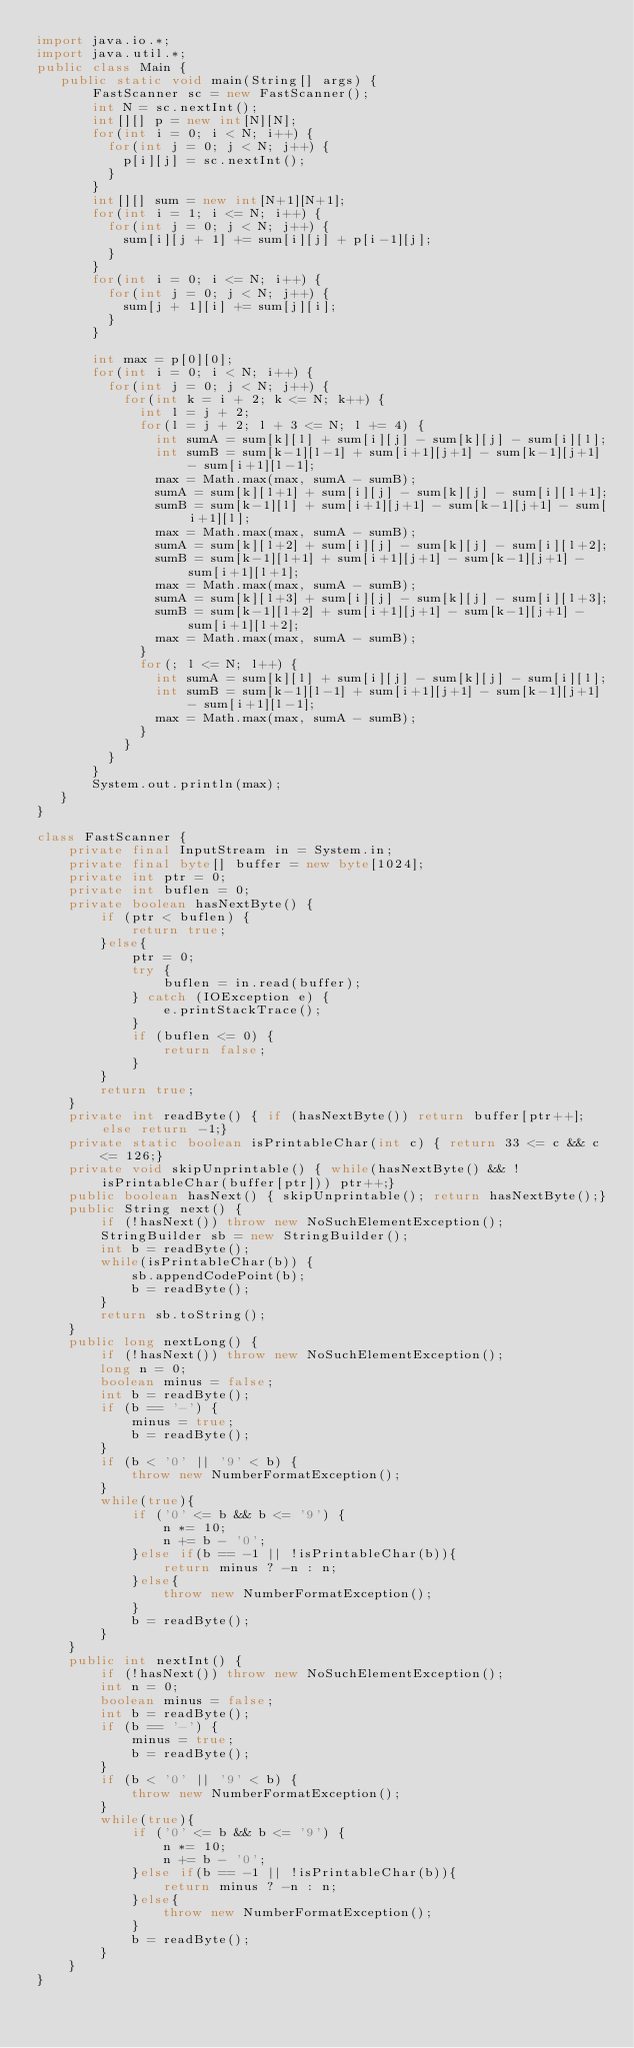<code> <loc_0><loc_0><loc_500><loc_500><_Java_>import java.io.*;
import java.util.*;
public class Main {
   public static void main(String[] args) {
       FastScanner sc = new FastScanner();
       int N = sc.nextInt();
       int[][] p = new int[N][N];
       for(int i = 0; i < N; i++) {
    	   for(int j = 0; j < N; j++) {
    		   p[i][j] = sc.nextInt();
    	   }
       }
       int[][] sum = new int[N+1][N+1];
       for(int i = 1; i <= N; i++) {
    	   for(int j = 0; j < N; j++) {
    		   sum[i][j + 1] += sum[i][j] + p[i-1][j];
    	   }
       }
       for(int i = 0; i <= N; i++) {
    	   for(int j = 0; j < N; j++) {
    		   sum[j + 1][i] += sum[j][i];
    	   }
       }
       
       int max = p[0][0];
       for(int i = 0; i < N; i++) {
    	   for(int j = 0; j < N; j++) {
    		   for(int k = i + 2; k <= N; k++) {
    			   int l = j + 2;
    			   for(l = j + 2; l + 3 <= N; l += 4) {
    				   int sumA = sum[k][l] + sum[i][j] - sum[k][j] - sum[i][l];
    				   int sumB = sum[k-1][l-1] + sum[i+1][j+1] - sum[k-1][j+1] - sum[i+1][l-1];
    				   max = Math.max(max, sumA - sumB);
    				   sumA = sum[k][l+1] + sum[i][j] - sum[k][j] - sum[i][l+1];
    				   sumB = sum[k-1][l] + sum[i+1][j+1] - sum[k-1][j+1] - sum[i+1][l];
    				   max = Math.max(max, sumA - sumB);
    				   sumA = sum[k][l+2] + sum[i][j] - sum[k][j] - sum[i][l+2];
    				   sumB = sum[k-1][l+1] + sum[i+1][j+1] - sum[k-1][j+1] - sum[i+1][l+1];
    				   max = Math.max(max, sumA - sumB);
    				   sumA = sum[k][l+3] + sum[i][j] - sum[k][j] - sum[i][l+3];
    				   sumB = sum[k-1][l+2] + sum[i+1][j+1] - sum[k-1][j+1] - sum[i+1][l+2];
    				   max = Math.max(max, sumA - sumB);
    			   }
    			   for(; l <= N; l++) {
    				   int sumA = sum[k][l] + sum[i][j] - sum[k][j] - sum[i][l];
    				   int sumB = sum[k-1][l-1] + sum[i+1][j+1] - sum[k-1][j+1] - sum[i+1][l-1];
    				   max = Math.max(max, sumA - sumB);
    			   }
    		   }
    	   }
       }
       System.out.println(max);
   }
}

class FastScanner {
    private final InputStream in = System.in;
    private final byte[] buffer = new byte[1024];
    private int ptr = 0;
    private int buflen = 0;
    private boolean hasNextByte() {
        if (ptr < buflen) {
            return true;
        }else{
            ptr = 0;
            try {
                buflen = in.read(buffer);
            } catch (IOException e) {
                e.printStackTrace();
            }
            if (buflen <= 0) {
                return false;
            }
        }
        return true;
    }
    private int readByte() { if (hasNextByte()) return buffer[ptr++]; else return -1;}
    private static boolean isPrintableChar(int c) { return 33 <= c && c <= 126;}
    private void skipUnprintable() { while(hasNextByte() && !isPrintableChar(buffer[ptr])) ptr++;}
    public boolean hasNext() { skipUnprintable(); return hasNextByte();}
    public String next() {
        if (!hasNext()) throw new NoSuchElementException();
        StringBuilder sb = new StringBuilder();
        int b = readByte();
        while(isPrintableChar(b)) {
            sb.appendCodePoint(b);
            b = readByte();
        }
        return sb.toString();
    }
    public long nextLong() {
        if (!hasNext()) throw new NoSuchElementException();
        long n = 0;
        boolean minus = false;
        int b = readByte();
        if (b == '-') {
            minus = true;
            b = readByte();
        }
        if (b < '0' || '9' < b) {
            throw new NumberFormatException();
        }
        while(true){
            if ('0' <= b && b <= '9') {
                n *= 10;
                n += b - '0';
            }else if(b == -1 || !isPrintableChar(b)){
                return minus ? -n : n;
            }else{
                throw new NumberFormatException();
            }
            b = readByte();
        }
    }
    public int nextInt() {
        if (!hasNext()) throw new NoSuchElementException();
        int n = 0;
        boolean minus = false;
        int b = readByte();
        if (b == '-') {
            minus = true;
            b = readByte();
        }
        if (b < '0' || '9' < b) {
            throw new NumberFormatException();
        }
        while(true){
            if ('0' <= b && b <= '9') {
                n *= 10;
                n += b - '0';
            }else if(b == -1 || !isPrintableChar(b)){
                return minus ? -n : n;
            }else{
                throw new NumberFormatException();
            }
            b = readByte();
        }
    }
}</code> 